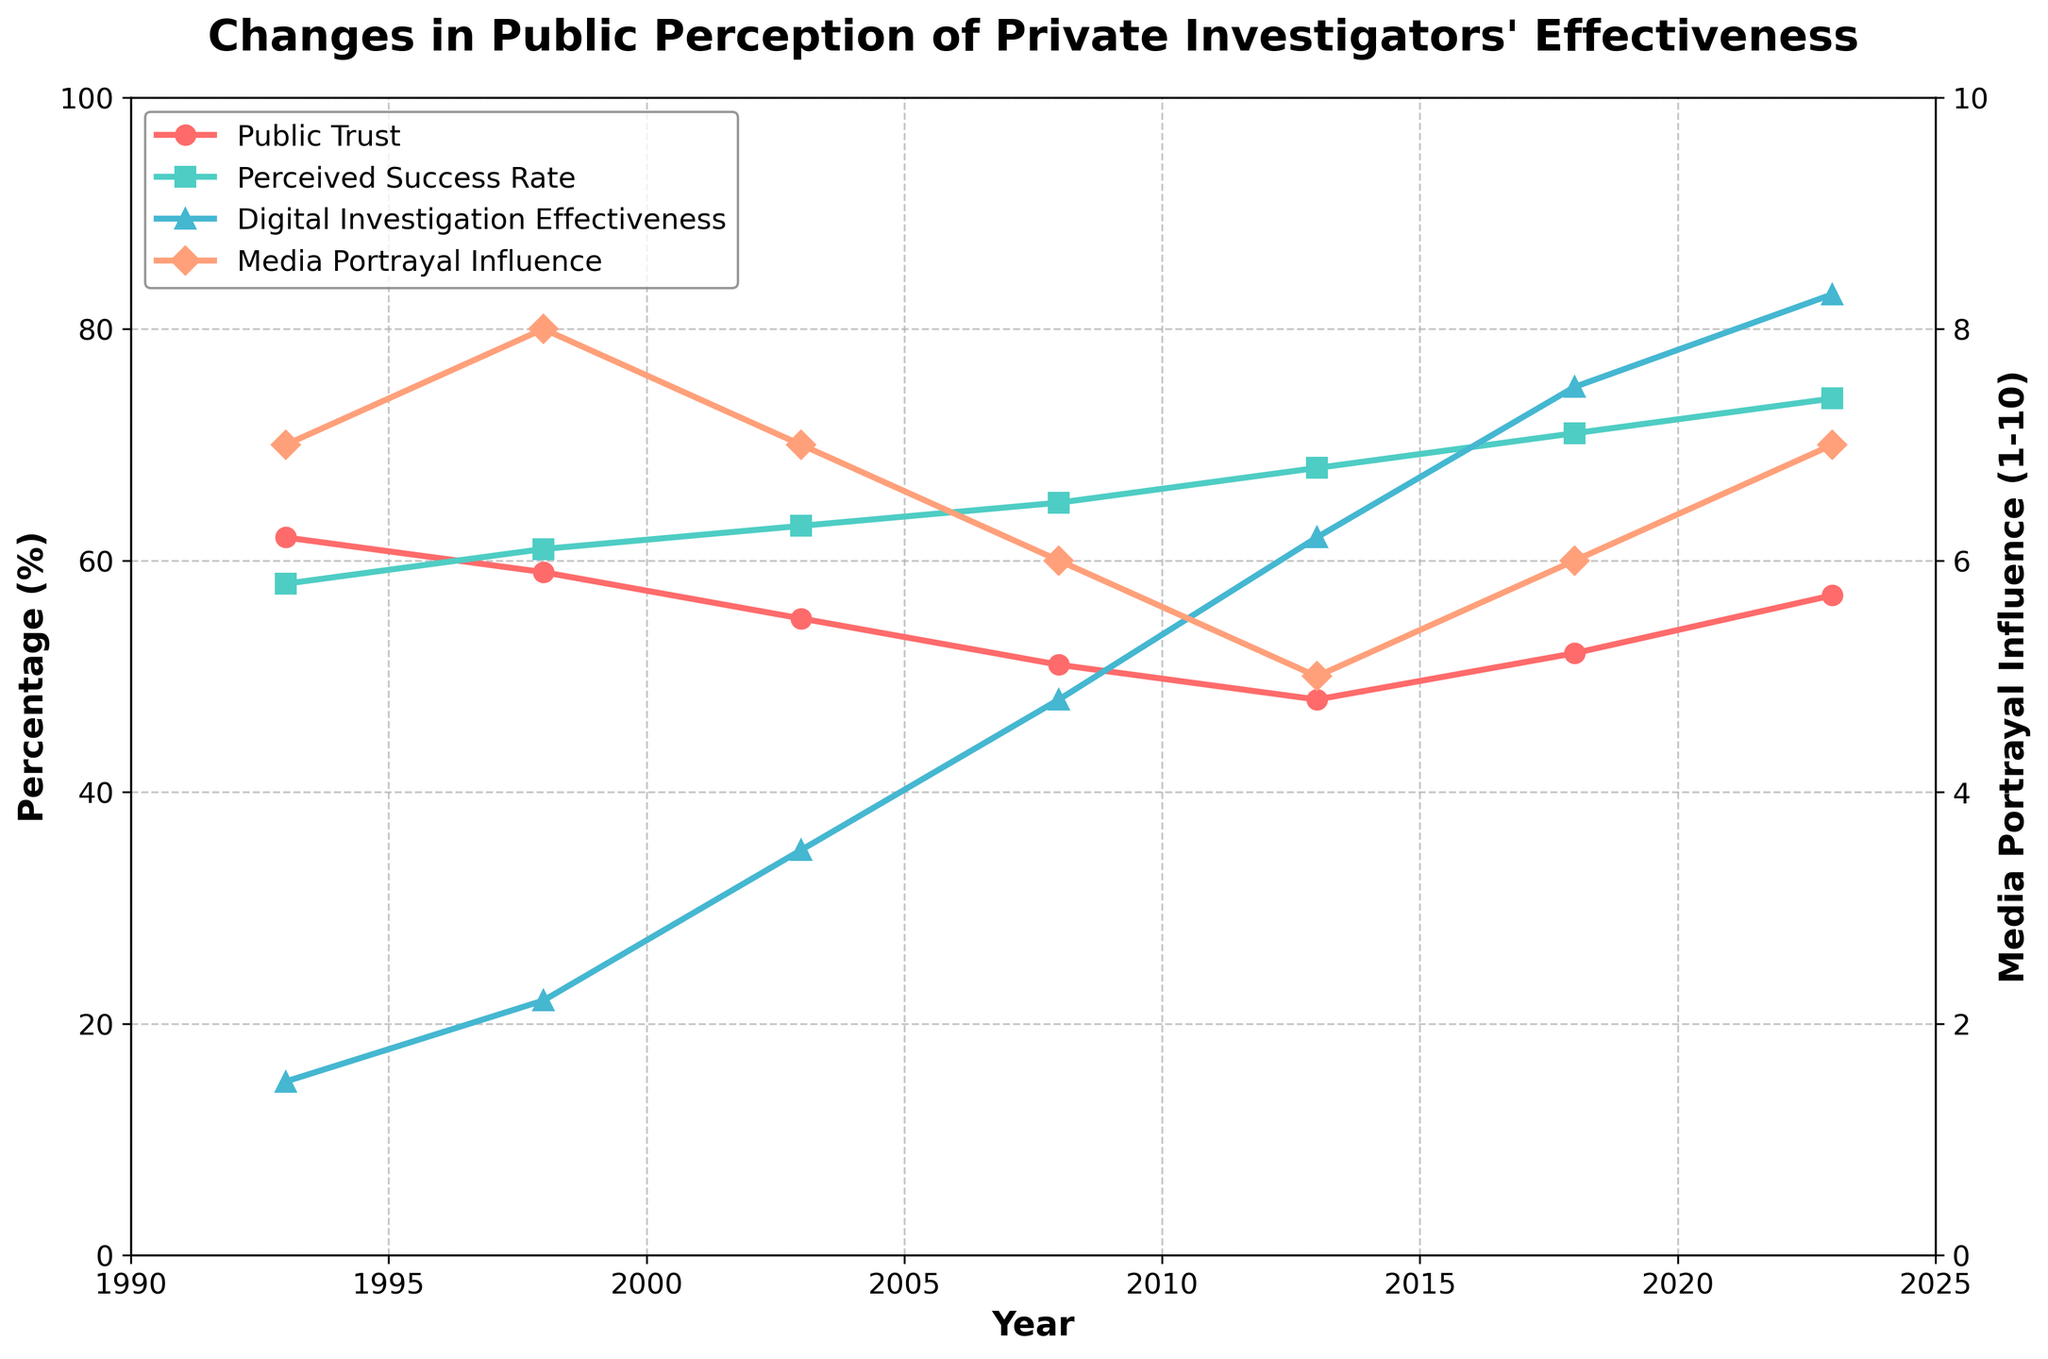What is the trend in public trust towards private investigators from 1993 to 2023? Look at the line representing "Public Trust (%)." It starts at 62% in 1993, decreases until 2013, then begins to increase again until 2023. The trend is a decrease followed by an increase.
Answer: Decrease, then increase How did the perceived success rate change from 1998 to 2023? Look at the line for "Perceived Success Rate (%)." It increases from 61% in 1998 to 74% in 2023.
Answer: Increased Which metric had the most significant increase from 1993 to 2023? Compare the starting and ending values of each metric. "Digital Investigation Effectiveness (%)" went from 15% in 1993 to 83% in 2023, an increase of 68%.
Answer: Digital Investigation Effectiveness In what year did public trust hit its lowest point? Look at the "Public Trust (%)" line and find the lowest value. The lowest value is 48% in 2013.
Answer: 2013 What is the relationship between media portrayal influence and public trust in 2013? In 2013, "Media Portrayal Influence (1-10)" is at 5, which is its lowest value on the chart, while "Public Trust (%)" is also at its lowest at 48%. This suggests a potential correlation between lower media portrayal influence and lower public trust in that year.
Answer: Both are at their lowest in 2013 What is the average perceived success rate over the three decades? Sum the "Perceived Success Rate (%)" values for each year and divide by the number of years (58+61+63+65+68+71+74)/7 = 460/7 ≈ 65.71
Answer: ≈ 65.71 How does the change in media portrayal influence from 1993 to 2023 compare with the change in public trust over the same period? The "Media Portrayal Influence (1-10)" changed from 7 to 7, showing no overall change. "Public Trust (%)" changed from 62% to 57%, a decrease of 5%.
Answer: Public Trust decreased by 5%, Media Portrayal Influence unchanged What is the difference between the perceived success rate (%) and digital investigation effectiveness (%) in 2003? Subtract the "Digital Investigation Effectiveness (%)" from the "Perceived Success Rate (%)" for 2003. 63% - 35% = 28%
Answer: 28% Which year saw the highest increase in digital investigation effectiveness and what was the increase? Calculate the year-to-year increase and find the maximum. The highest increase is between 2008 and 2013, from 48% to 62%. The increase is 62% - 48% = 14%.
Answer: 2013, 14% In what period did public trust see a reversal in its trend, and what was the change in percentage points during this period? Find where "Public Trust (%)" switches from decreasing to increasing. This occurs between 2013 and 2018, from 48% to 52%, a change of 4 percentage points.
Answer: 2013-2018, 4 percentage points 